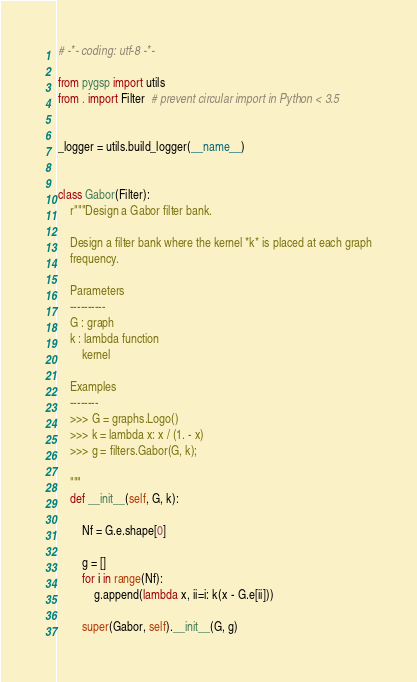Convert code to text. <code><loc_0><loc_0><loc_500><loc_500><_Python_># -*- coding: utf-8 -*-

from pygsp import utils
from . import Filter  # prevent circular import in Python < 3.5


_logger = utils.build_logger(__name__)


class Gabor(Filter):
    r"""Design a Gabor filter bank.

    Design a filter bank where the kernel *k* is placed at each graph
    frequency.

    Parameters
    ----------
    G : graph
    k : lambda function
        kernel

    Examples
    --------
    >>> G = graphs.Logo()
    >>> k = lambda x: x / (1. - x)
    >>> g = filters.Gabor(G, k);

    """
    def __init__(self, G, k):

        Nf = G.e.shape[0]

        g = []
        for i in range(Nf):
            g.append(lambda x, ii=i: k(x - G.e[ii]))

        super(Gabor, self).__init__(G, g)
</code> 